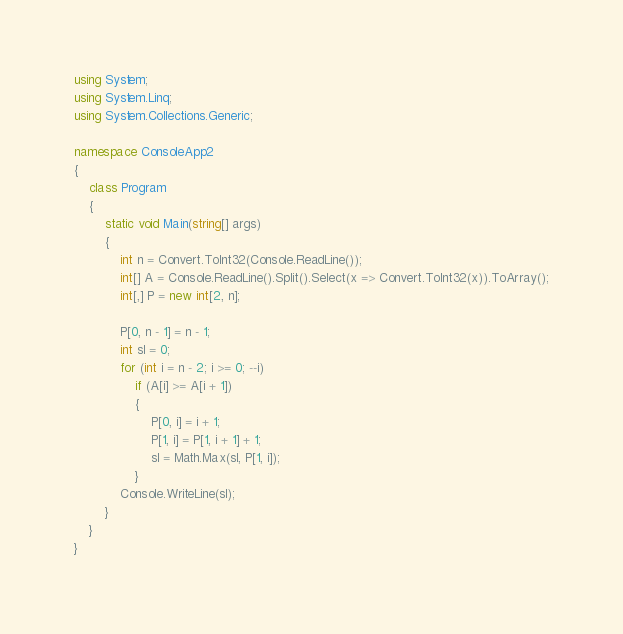<code> <loc_0><loc_0><loc_500><loc_500><_C#_>using System;
using System.Linq;
using System.Collections.Generic;

namespace ConsoleApp2
{
    class Program
    {
        static void Main(string[] args)
        {
            int n = Convert.ToInt32(Console.ReadLine());
            int[] A = Console.ReadLine().Split().Select(x => Convert.ToInt32(x)).ToArray();
            int[,] P = new int[2, n];

            P[0, n - 1] = n - 1;
            int sl = 0;
            for (int i = n - 2; i >= 0; --i)
                if (A[i] >= A[i + 1])
                {
                    P[0, i] = i + 1;
                    P[1, i] = P[1, i + 1] + 1;
                    sl = Math.Max(sl, P[1, i]);
                }
            Console.WriteLine(sl);
        }
    }
}
</code> 